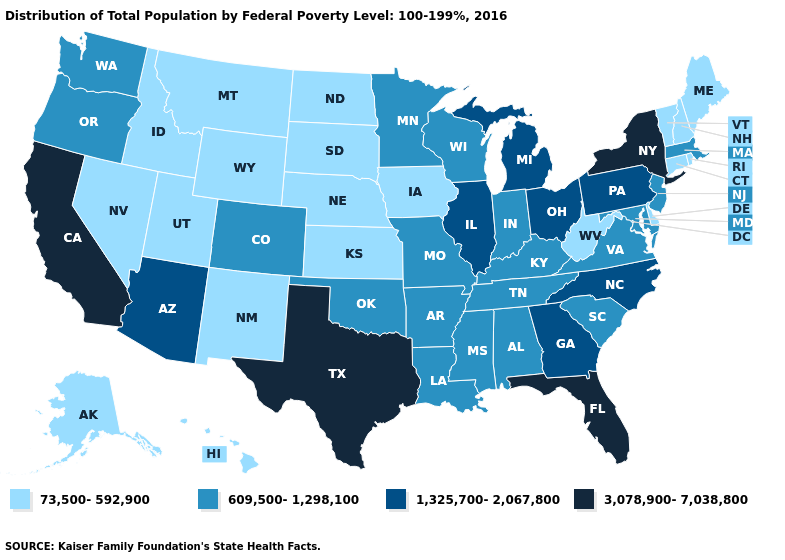Which states have the lowest value in the Northeast?
Short answer required. Connecticut, Maine, New Hampshire, Rhode Island, Vermont. Among the states that border California , which have the lowest value?
Keep it brief. Nevada. What is the value of Massachusetts?
Keep it brief. 609,500-1,298,100. What is the value of Florida?
Keep it brief. 3,078,900-7,038,800. Which states hav the highest value in the Northeast?
Write a very short answer. New York. Is the legend a continuous bar?
Be succinct. No. Does the map have missing data?
Quick response, please. No. What is the value of Vermont?
Be succinct. 73,500-592,900. Is the legend a continuous bar?
Answer briefly. No. Name the states that have a value in the range 1,325,700-2,067,800?
Be succinct. Arizona, Georgia, Illinois, Michigan, North Carolina, Ohio, Pennsylvania. Among the states that border Oklahoma , does Missouri have the lowest value?
Be succinct. No. Name the states that have a value in the range 3,078,900-7,038,800?
Quick response, please. California, Florida, New York, Texas. Name the states that have a value in the range 73,500-592,900?
Concise answer only. Alaska, Connecticut, Delaware, Hawaii, Idaho, Iowa, Kansas, Maine, Montana, Nebraska, Nevada, New Hampshire, New Mexico, North Dakota, Rhode Island, South Dakota, Utah, Vermont, West Virginia, Wyoming. Among the states that border Washington , which have the lowest value?
Answer briefly. Idaho. 